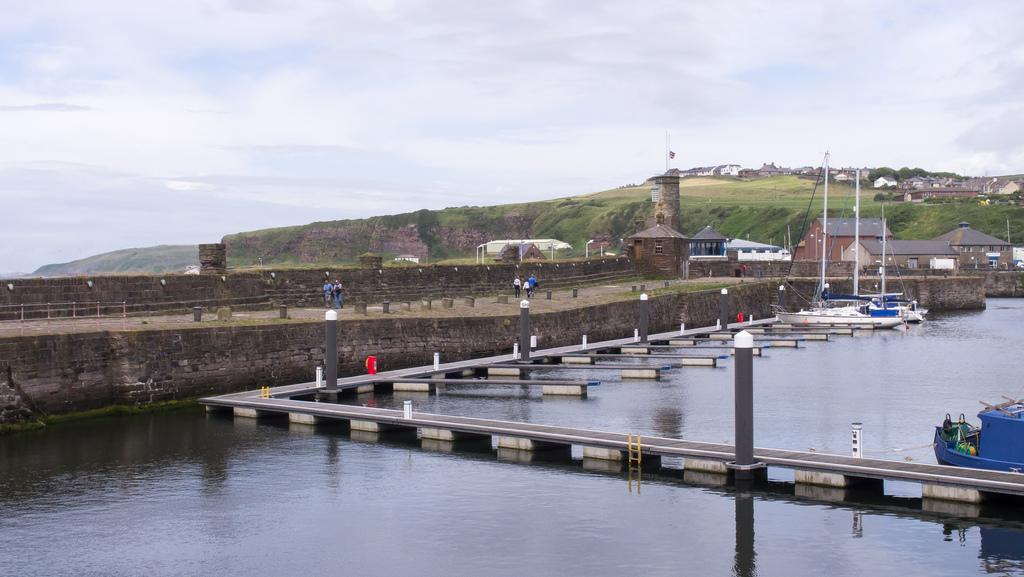What is on the water in the image? There are boats on the water in the image. What structure is present near the water in the image? There is a pier on the water in the image. Who can be seen in the image? There are groups of people in the image. What type of buildings are visible in the image? There are houses in the image. What type of vegetation is present in the image? There are trees in the image. What is visible in the background of the image? The sky is visible in the background of the image. Can you tell me where the blade of grass is located in the image? There is no blade of grass present in the image. What type of quicksand can be seen in the image? There is no quicksand present in the image. 